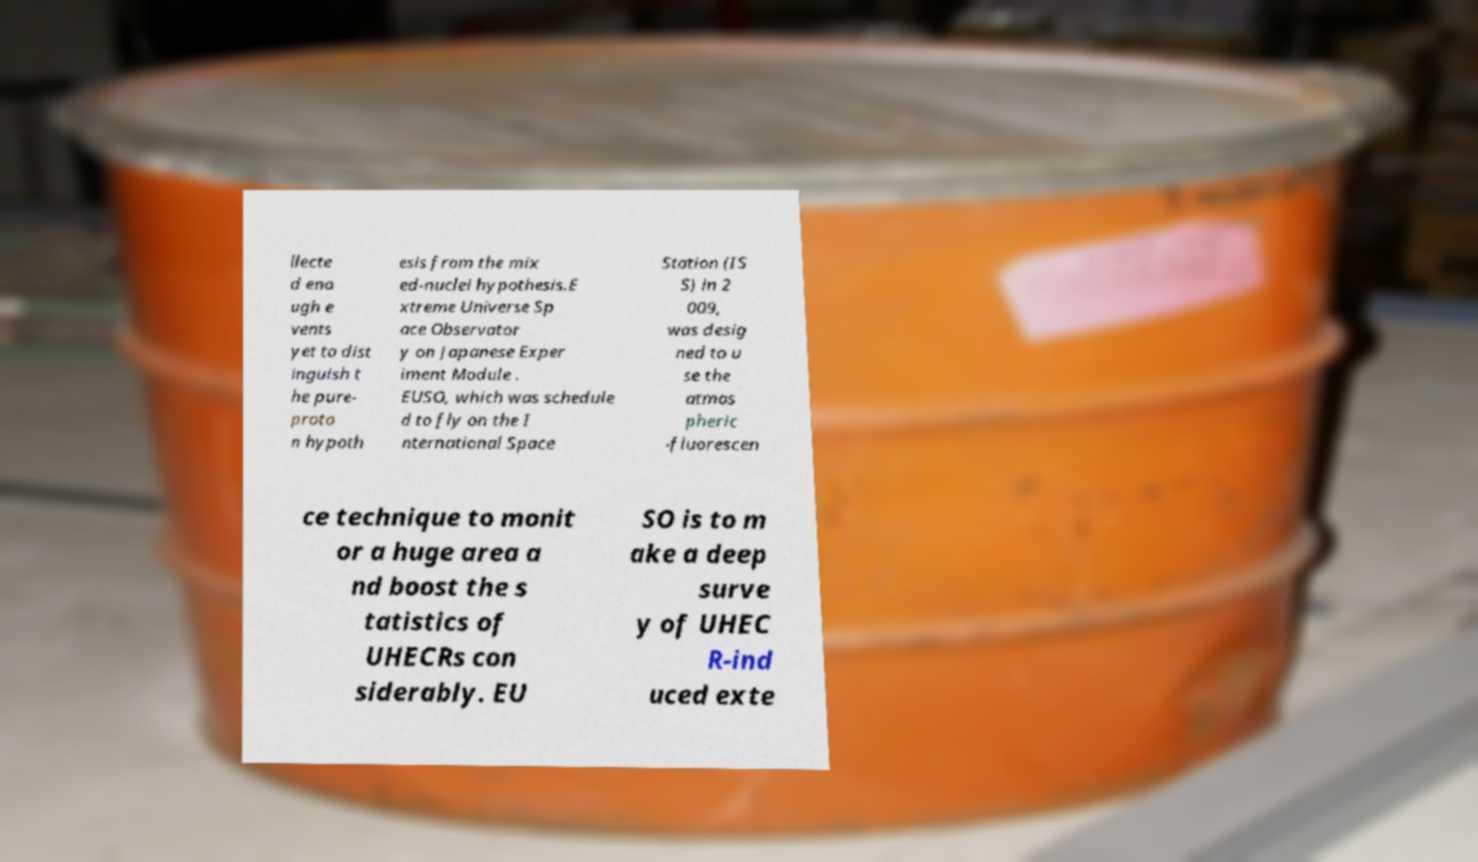Can you accurately transcribe the text from the provided image for me? llecte d eno ugh e vents yet to dist inguish t he pure- proto n hypoth esis from the mix ed-nuclei hypothesis.E xtreme Universe Sp ace Observator y on Japanese Exper iment Module . EUSO, which was schedule d to fly on the I nternational Space Station (IS S) in 2 009, was desig ned to u se the atmos pheric -fluorescen ce technique to monit or a huge area a nd boost the s tatistics of UHECRs con siderably. EU SO is to m ake a deep surve y of UHEC R-ind uced exte 